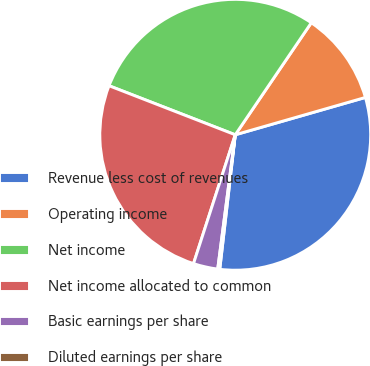<chart> <loc_0><loc_0><loc_500><loc_500><pie_chart><fcel>Revenue less cost of revenues<fcel>Operating income<fcel>Net income<fcel>Net income allocated to common<fcel>Basic earnings per share<fcel>Diluted earnings per share<nl><fcel>31.27%<fcel>11.06%<fcel>28.59%<fcel>25.91%<fcel>2.92%<fcel>0.24%<nl></chart> 